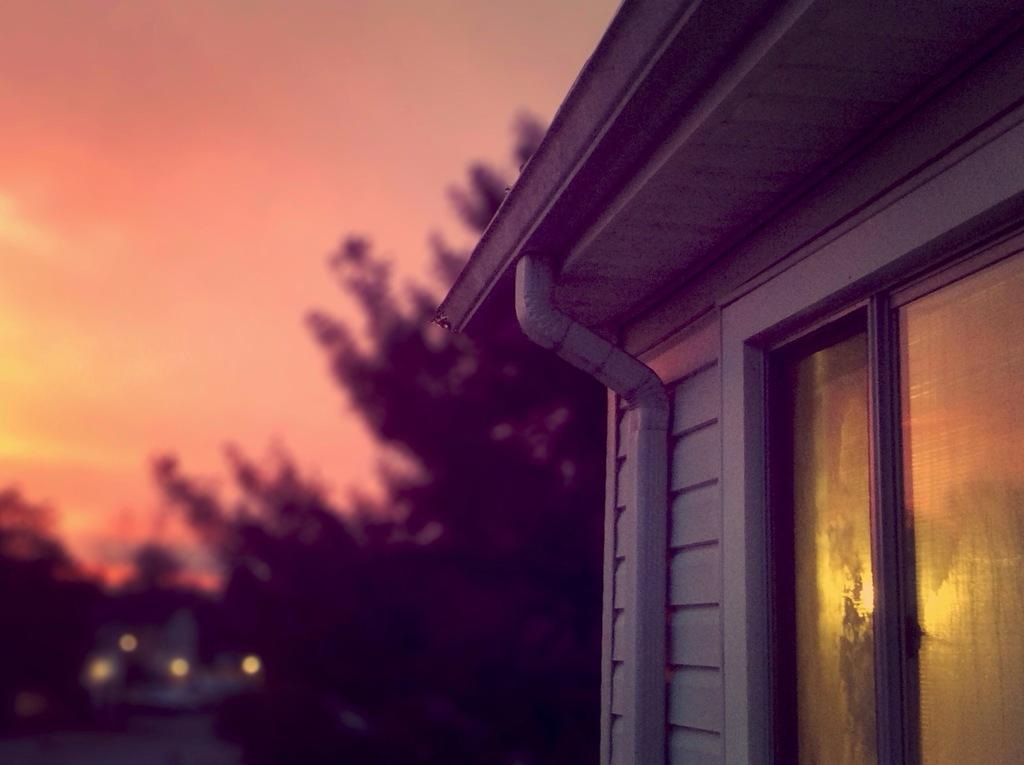What is the main structure visible in the image? There is a building in the image. What type of natural element can be seen in the background of the image? There is a tree in the background of the image. How would you describe the quality of the image in the background? The image may be slightly blurry in the background. What type of leg is visible in the image? There is no leg visible in the image; it features a building and a tree in the background. 